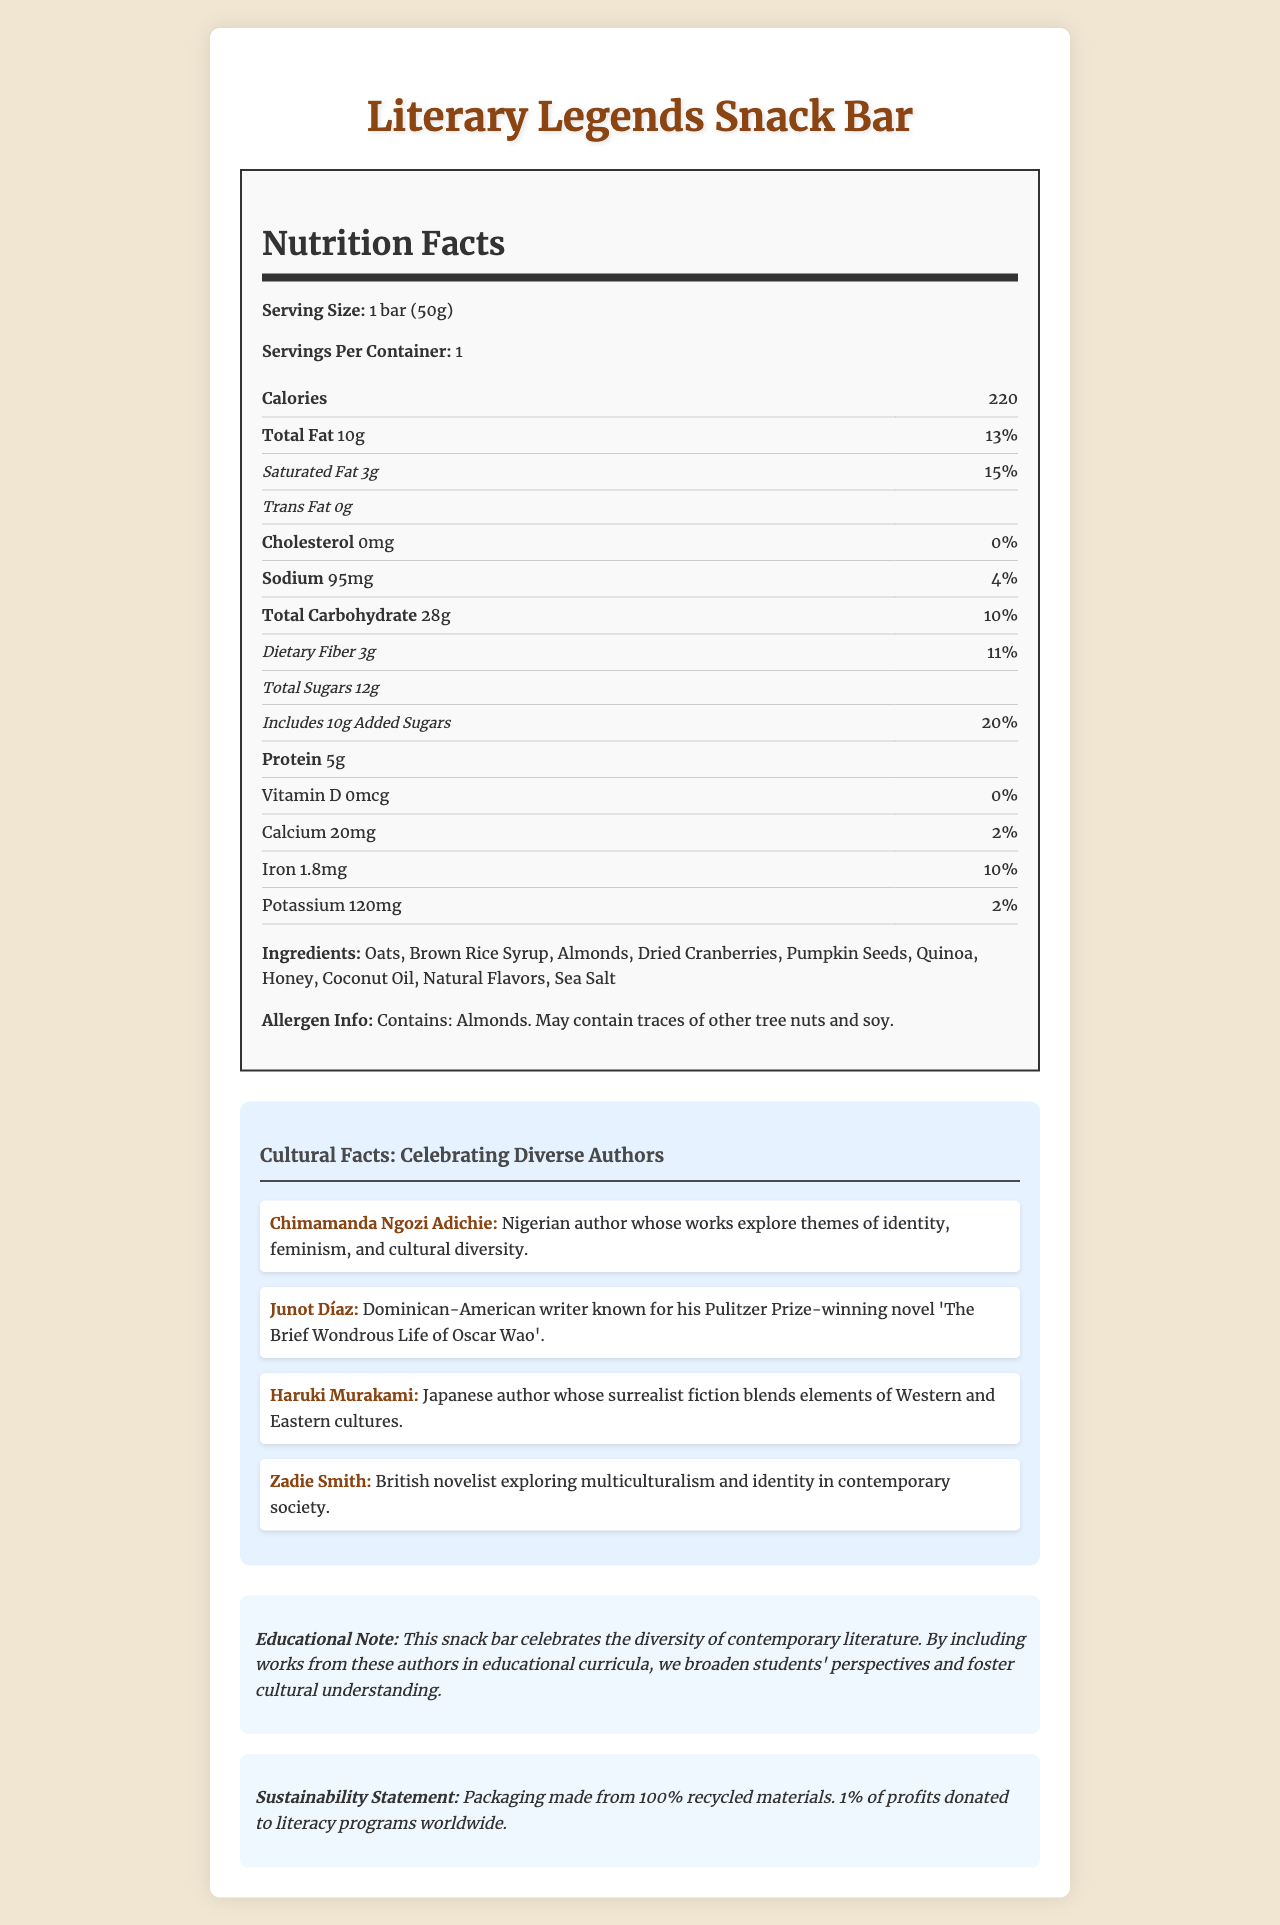what is the serving size of the Literary Legends Snack Bar? The serving size is explicitly mentioned as "1 bar (50g)" in the document.
Answer: 1 bar (50g) how many calories are in one serving of the snack bar? The document lists the calorie count as 220 per serving.
Answer: 220 what is the percentage of daily value for saturated fat? The percentage daily value for saturated fat is indicated as 15% in the nutrition facts.
Answer: 15% name three ingredients found in the Literary Legends Snack Bar. Three of the ingredients listed are Oats, Almonds, and Dried Cranberries.
Answer: Oats, Almonds, Dried Cranberries what amount of iron does the snack bar contain? The snack bar contains 1.8mg of iron.
Answer: 1.8mg which author is known for blending elements of Western and Eastern cultures? A. Chimamanda Ngozi Adichie B. Junot Díaz C. Haruki Murakami D. Zadie Smith Haruki Murakami is the author known for blending elements of Western and Eastern cultures.
Answer: C what are the potential allergens in the Literary Legends Snack Bar? A. Almonds and Dairy B. Almonds and Soy C. Soy and Wheat D. Peanuts and Soy The document states that the snack bar contains almonds and may contain traces of other tree nuts and soy.
Answer: B does the snack bar contain any cholesterol? The document states that the cholesterol amount is 0mg, indicating no cholesterol.
Answer: No is the packaging of the snack bar sustainable? The sustainability statement mentions that the packaging is made from 100% recycled materials.
Answer: Yes summarize the main idea of the document. The document provides a comprehensive overview of the Literary Legends Snack Bar, including its nutritional breakdown, ingredient list, allergen information, cultural facts about authors, an educational note, and a sustainability statement.
Answer: The Literary Legends Snack Bar is a limited-edition snack celebrating diverse contemporary authors, featuring nutritional information, allergen warnings, and cultural facts about the authors. It promotes the inclusion of modern works in education and supports sustainability by using recycled packaging and donating a portion of profits to literacy programs. what is the exact percentage of daily value for vitamin D? The document mentions 0% Daily Value for Vitamin D but does not quantify the amount beyond stating "0mcg".
Answer: Not enough information does the snack bar contain any trans fat? The trans fat amount is listed as 0g in the nutrition facts.
Answer: No 